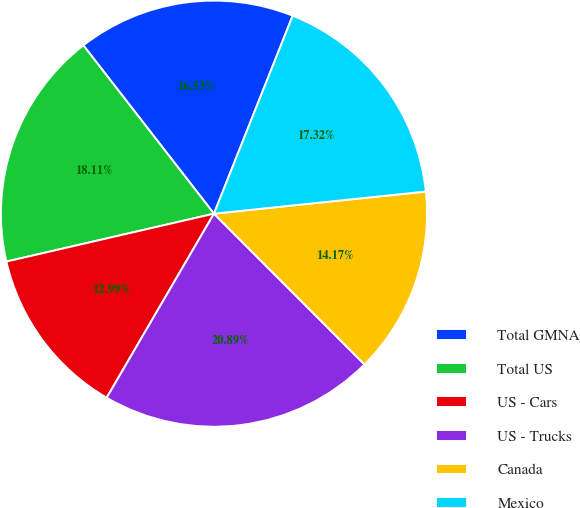Convert chart. <chart><loc_0><loc_0><loc_500><loc_500><pie_chart><fcel>Total GMNA<fcel>Total US<fcel>US - Cars<fcel>US - Trucks<fcel>Canada<fcel>Mexico<nl><fcel>16.53%<fcel>18.11%<fcel>12.99%<fcel>20.89%<fcel>14.17%<fcel>17.32%<nl></chart> 